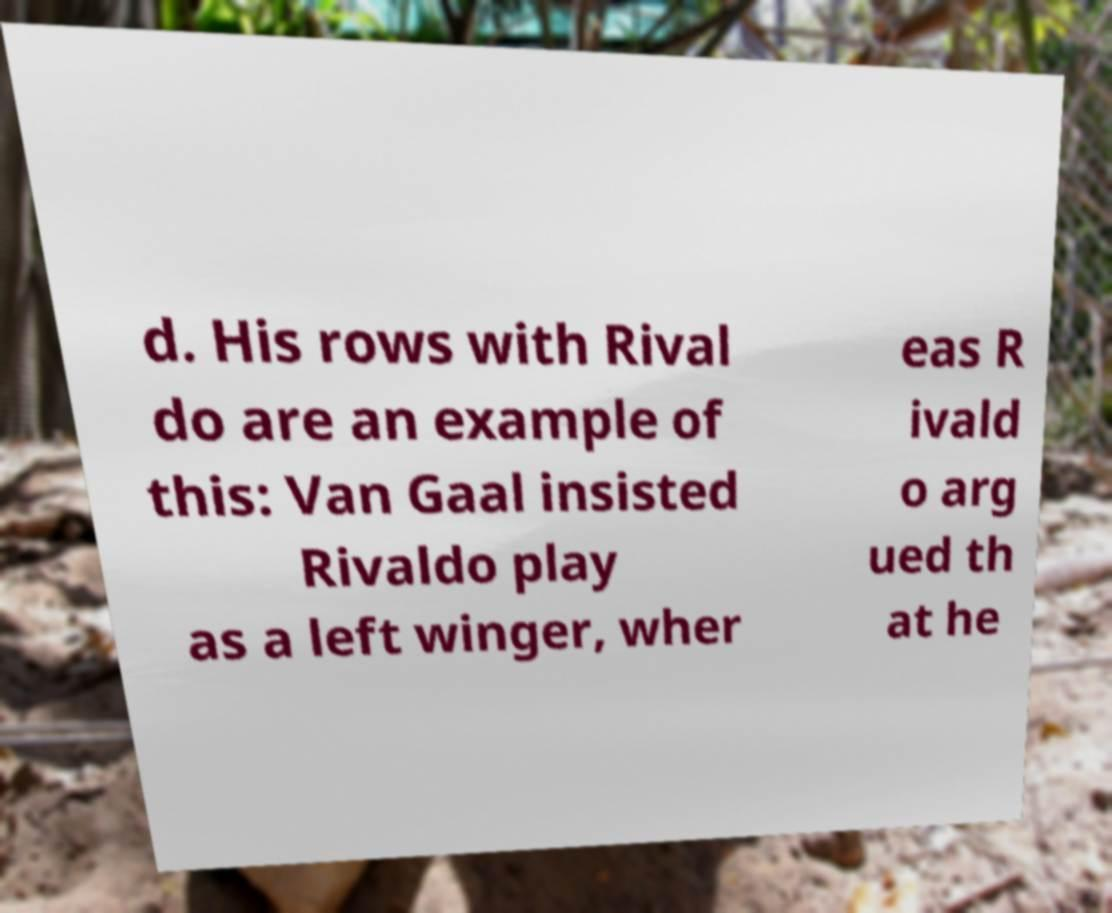Please read and relay the text visible in this image. What does it say? d. His rows with Rival do are an example of this: Van Gaal insisted Rivaldo play as a left winger, wher eas R ivald o arg ued th at he 